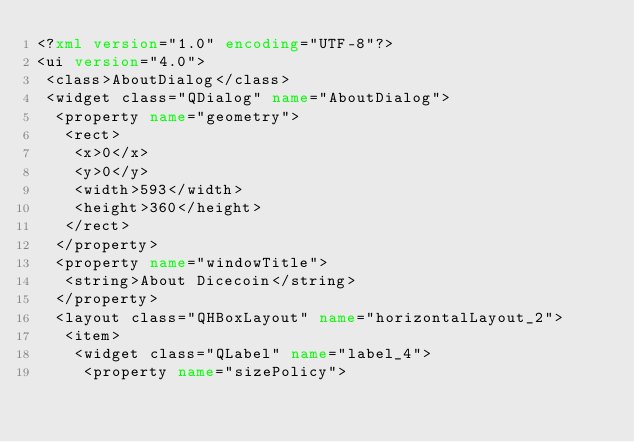<code> <loc_0><loc_0><loc_500><loc_500><_XML_><?xml version="1.0" encoding="UTF-8"?>
<ui version="4.0">
 <class>AboutDialog</class>
 <widget class="QDialog" name="AboutDialog">
  <property name="geometry">
   <rect>
    <x>0</x>
    <y>0</y>
    <width>593</width>
    <height>360</height>
   </rect>
  </property>
  <property name="windowTitle">
   <string>About Dicecoin</string>
  </property>
  <layout class="QHBoxLayout" name="horizontalLayout_2">
   <item>
    <widget class="QLabel" name="label_4">
     <property name="sizePolicy"></code> 